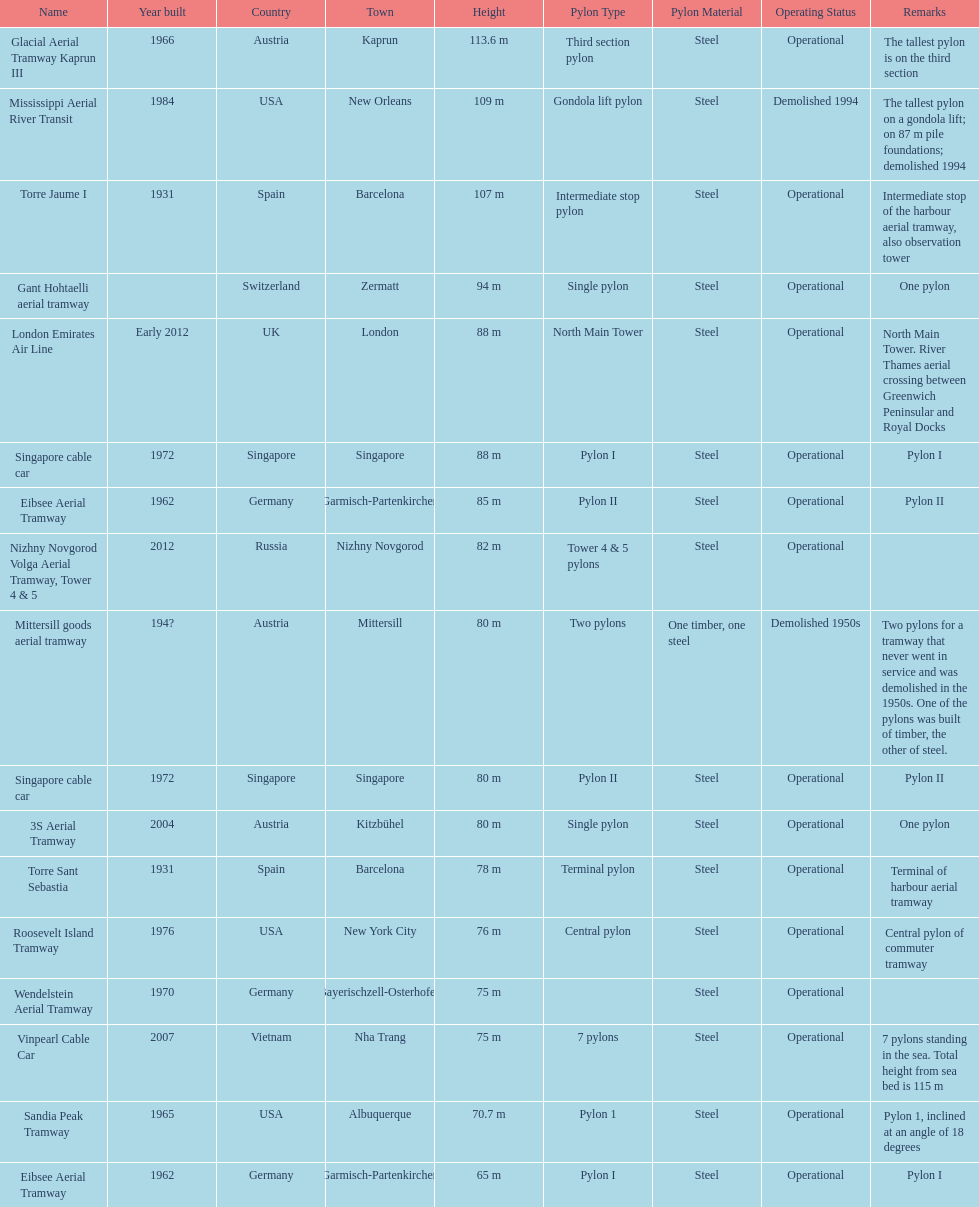What is the pylon with the least height listed here? Eibsee Aerial Tramway. 